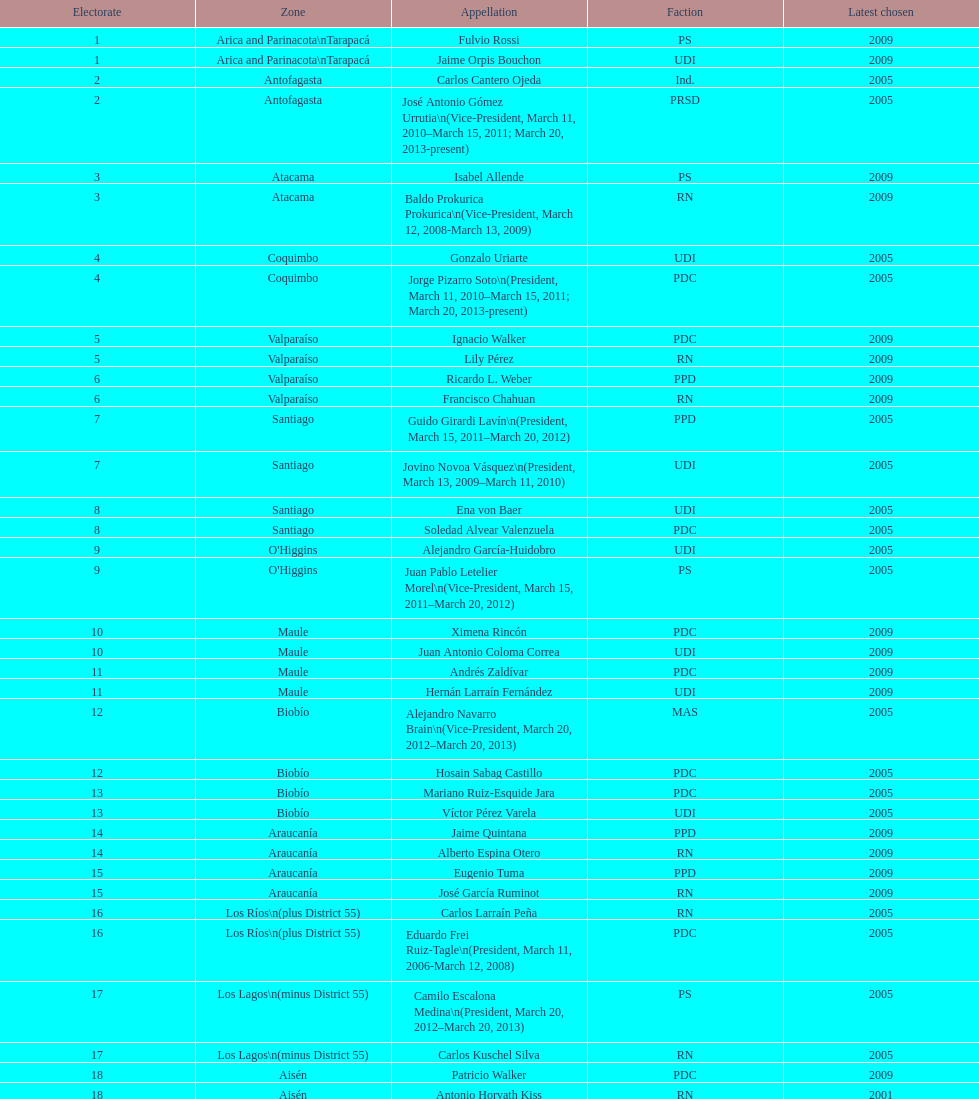Which region is listed below atacama? Coquimbo. 